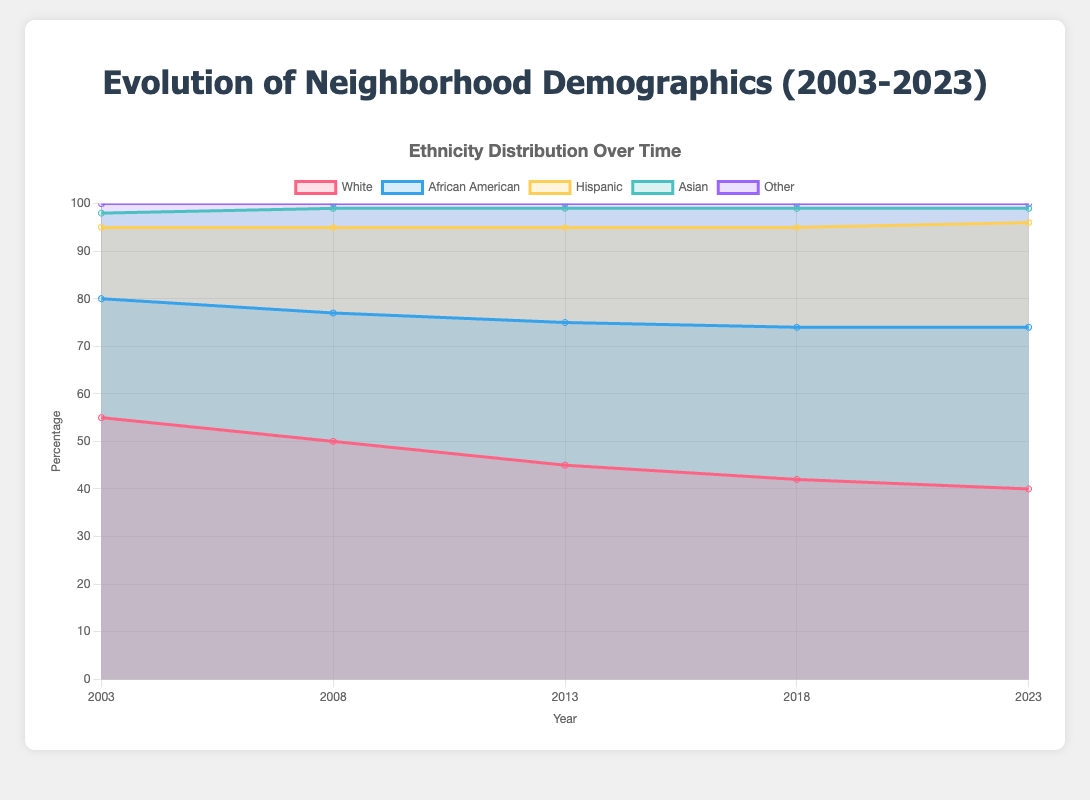What is the title of the figure? The title is usually found at the top of the chart and provides a summary of what the chart represents.
Answer: Evolution of Neighborhood Demographics (2003-2023) What is the percentage of the Hispanic population in 2013? To find this, locate the data point for the year 2013 and check the percentage for the Hispanic group.
Answer: 20% In what year did the neighborhood unemployment rate dip below 5%? Look at the unemployment rate for each year and identify the first year it drops below 5%.
Answer: 2018 How has the median income changed from 2003 to 2023? Compare the median income values for the years 2003 and 2023 to determine the change.
Answer: Increased by $17,000 (from $45,000 to $62,000) Which ethnic group saw the most significant increase in their proportion from 2003 to 2023? Compare the percentages of each ethnic group in 2003 and 2023 to identify the group with the largest increase.
Answer: African American (increase from 25% to 34%) What is the total percentage of non-White populations in 2008? Sum the percentages of African American, Hispanic, Asian, and Other groups for the year 2008.
Answer: 50% (27% + 18% + 4% + 1%) What trend can be observed in the Asian population over the years? Look at the percentages for the Asian population for all years to identify any trends.
Answer: Stayed relatively constant around 3-4% How much did the population increase between 2013 and 2018? Subtract the population of 2013 from that of 2018 to find the increase.
Answer: 1,000 people (from 15,000 to 16,000) Between 2008 and 2018, which ethnic group had the smallest change in percentage points? Compare the percentage changes for each group between 2008 and 2018 to identify the smallest change.
Answer: Other (decrease by 0.0%, stayed at 1%) From 2003 to 2023, how did the ratio of African American population to White population change? Calculate the ratios for both years and compare them.
Answer: 2003: 0.45 (25%/55%), 2023: 0.85 (34%/40%) 